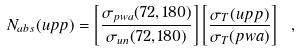Convert formula to latex. <formula><loc_0><loc_0><loc_500><loc_500>N _ { a b s } ( u p p ) = \left [ \frac { \sigma _ { p w a } ( 7 2 , 1 8 0 ) } { \sigma _ { u n } ( 7 2 , 1 8 0 ) } \right ] \left [ \frac { \sigma _ { T } ( u p p ) } { \sigma _ { T } ( p w a ) } \right ] \ ,</formula> 